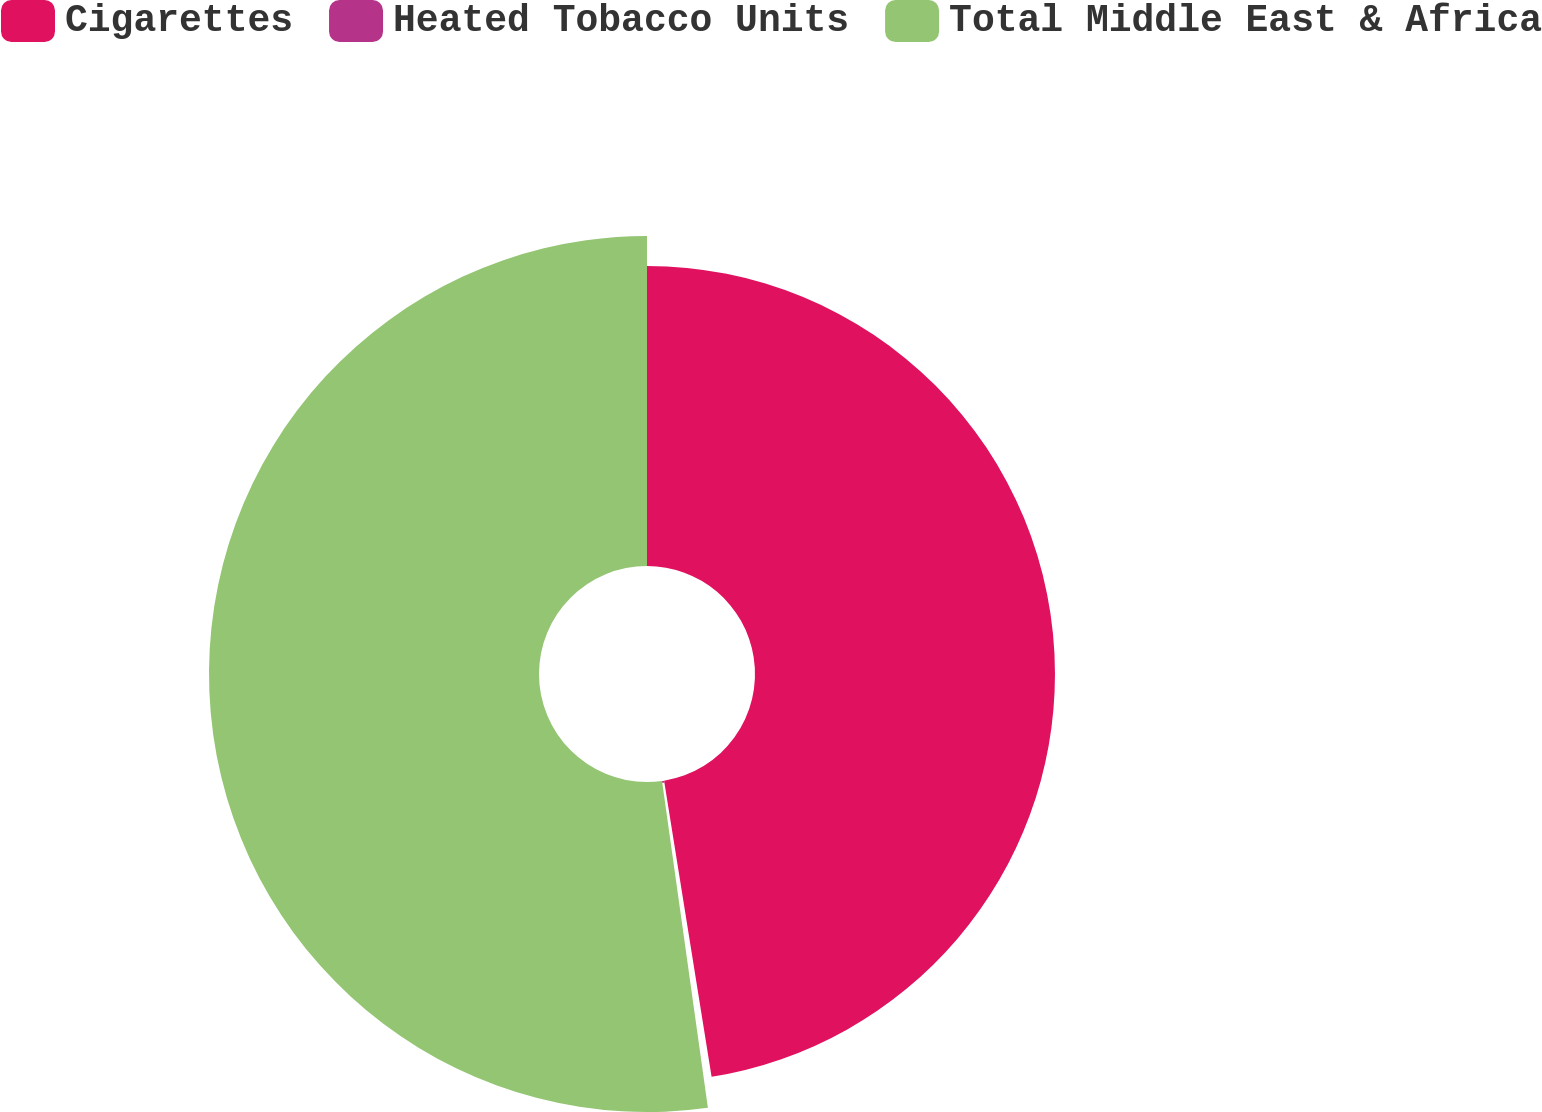Convert chart to OTSL. <chart><loc_0><loc_0><loc_500><loc_500><pie_chart><fcel>Cigarettes<fcel>Heated Tobacco Units<fcel>Total Middle East & Africa<nl><fcel>47.47%<fcel>0.31%<fcel>52.22%<nl></chart> 